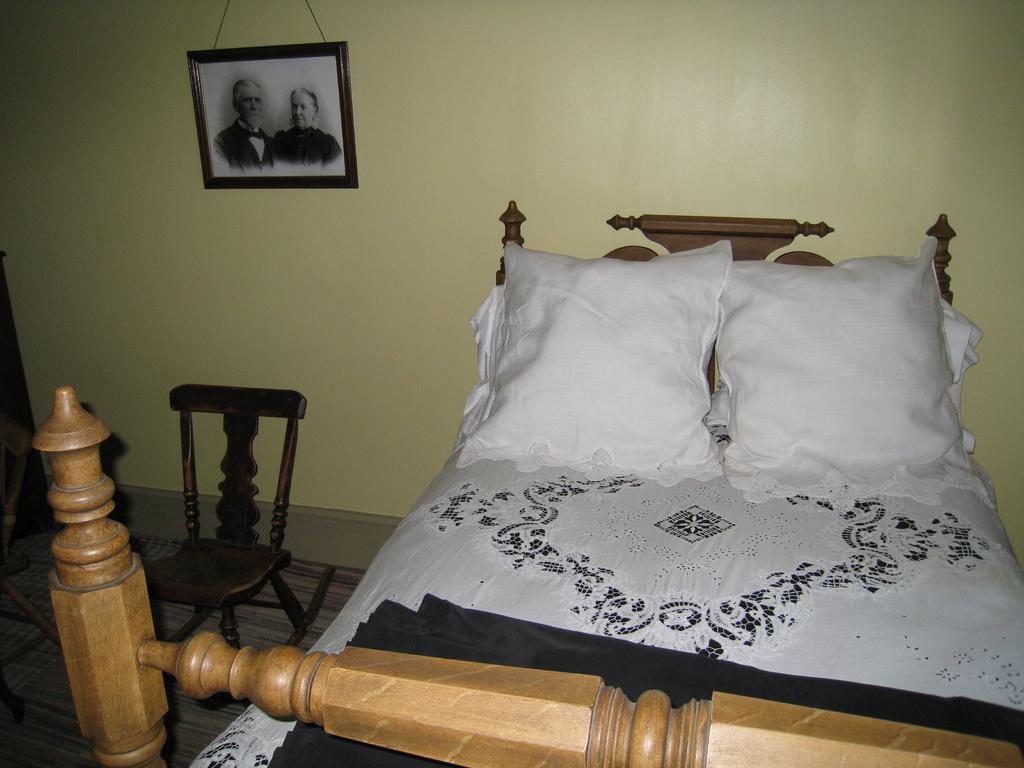What type of furniture is present in the room? There is a bed and a chair in the room. What is on the bed? The bed has pillows on it. Is there any decoration on the wall? Yes, there is a photo frame hanging on the wall. Reasoning: Let's think step by following the guidelines to produce the conversation. We start by identifying the main furniture pieces in the room, which are the bed and the chair. Then, we describe the details of the bed, mentioning the presence of pillows. Finally, we acknowledge the presence of a photo frame on the wall as a decorative element. Absurd Question/Answer: How does the crowd affect the plot in the image? There is no crowd or plot present in the image, as it only features a bed, pillows, a chair, and a photo frame in a room. 